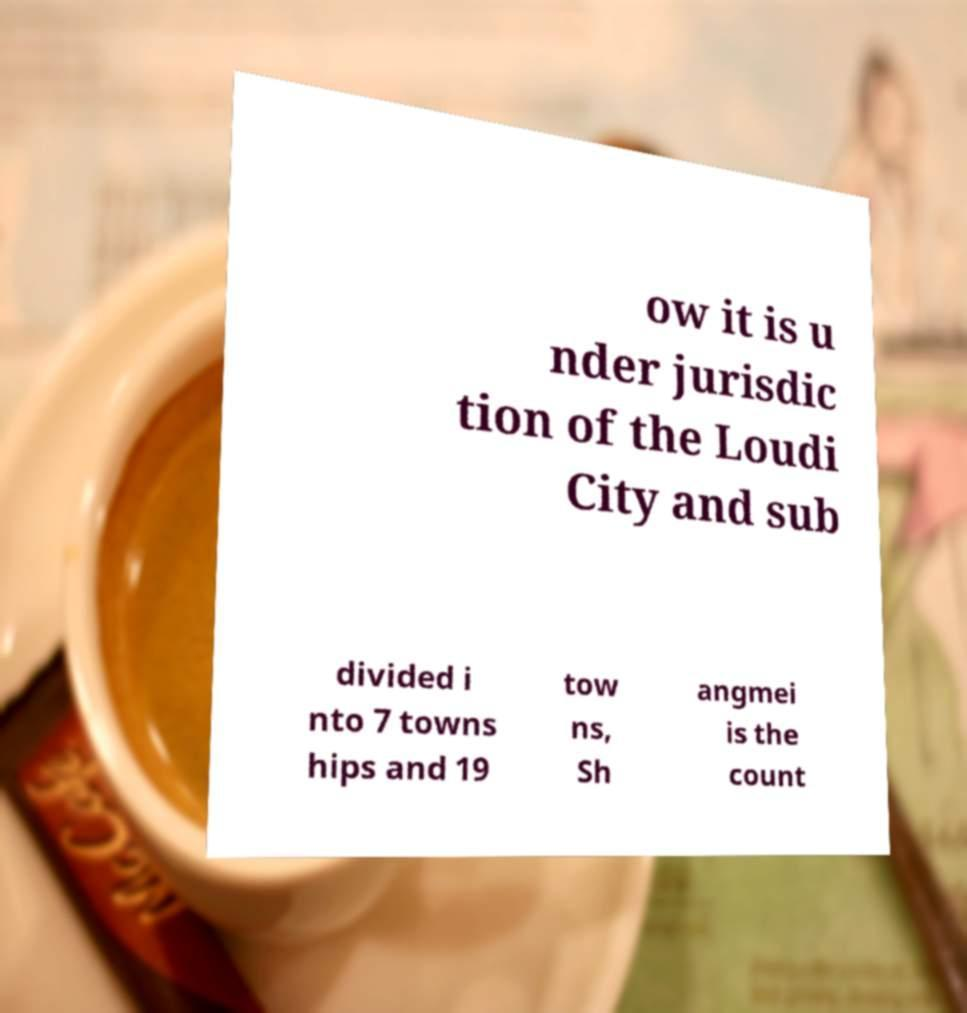Please read and relay the text visible in this image. What does it say? ow it is u nder jurisdic tion of the Loudi City and sub divided i nto 7 towns hips and 19 tow ns, Sh angmei is the count 